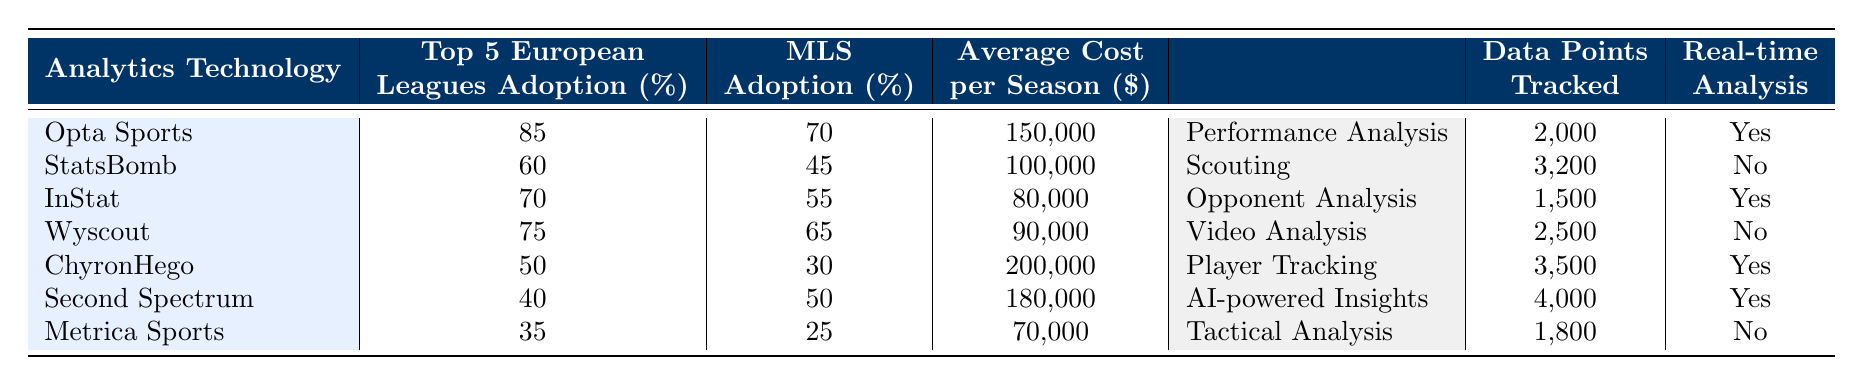What is the adoption rate of Opta Sports in the Top 5 European Leagues? The table shows that the adoption rate of Opta Sports in the Top 5 European Leagues is listed directly as 85%.
Answer: 85% Which analytics technology has the highest MLS adoption rate? By looking through the "MLS Adoption (%)" column, Opta Sports has the highest percentage at 70%.
Answer: Opta Sports How much does it cost on average per season to utilize ChyronHego analytics technology? From the table, the "Average Cost per Season" for ChyronHego is stated as 200,000 dollars.
Answer: 200,000 What is the difference in the Top 5 European Leagues adoption rate between StatsBomb and Wyscout? The adoption rates are 60% for StatsBomb and 75% for Wyscout. Calculating the difference gives 75% - 60% = 15%.
Answer: 15% Is real-time analysis available with Second Spectrum? According to the table, Second Spectrum indicates 'Yes' under the "Real-time Analysis" column, confirming that real-time analysis is available.
Answer: Yes What is the primary use case for InStat? The primary use case for InStat, as shown in the table, is "Opponent Analysis."
Answer: Opponent Analysis If a club wanted to track the most data points, which analytics technology should they choose? The technology that tracks the most data points is Second Spectrum, with a total of 4,000 data points tracked according to the table.
Answer: Second Spectrum What is the average adoption rate for the MLS across all listed technologies? To calculate the average, sum the MLS adoption rates (70 + 45 + 55 + 65 + 30 + 50 + 25 = 410) and divide by the number of technologies (7), giving 410/7 = 58.57%.
Answer: 58.57% How many technologies provide real-time analysis? By reviewing the "Real-time Analysis" column, it can be seen that five out of the seven technologies (Opta Sports, InStat, ChyronHego, Second Spectrum) have "Yes" listed, indicating their availability for real-time analysis.
Answer: 4 